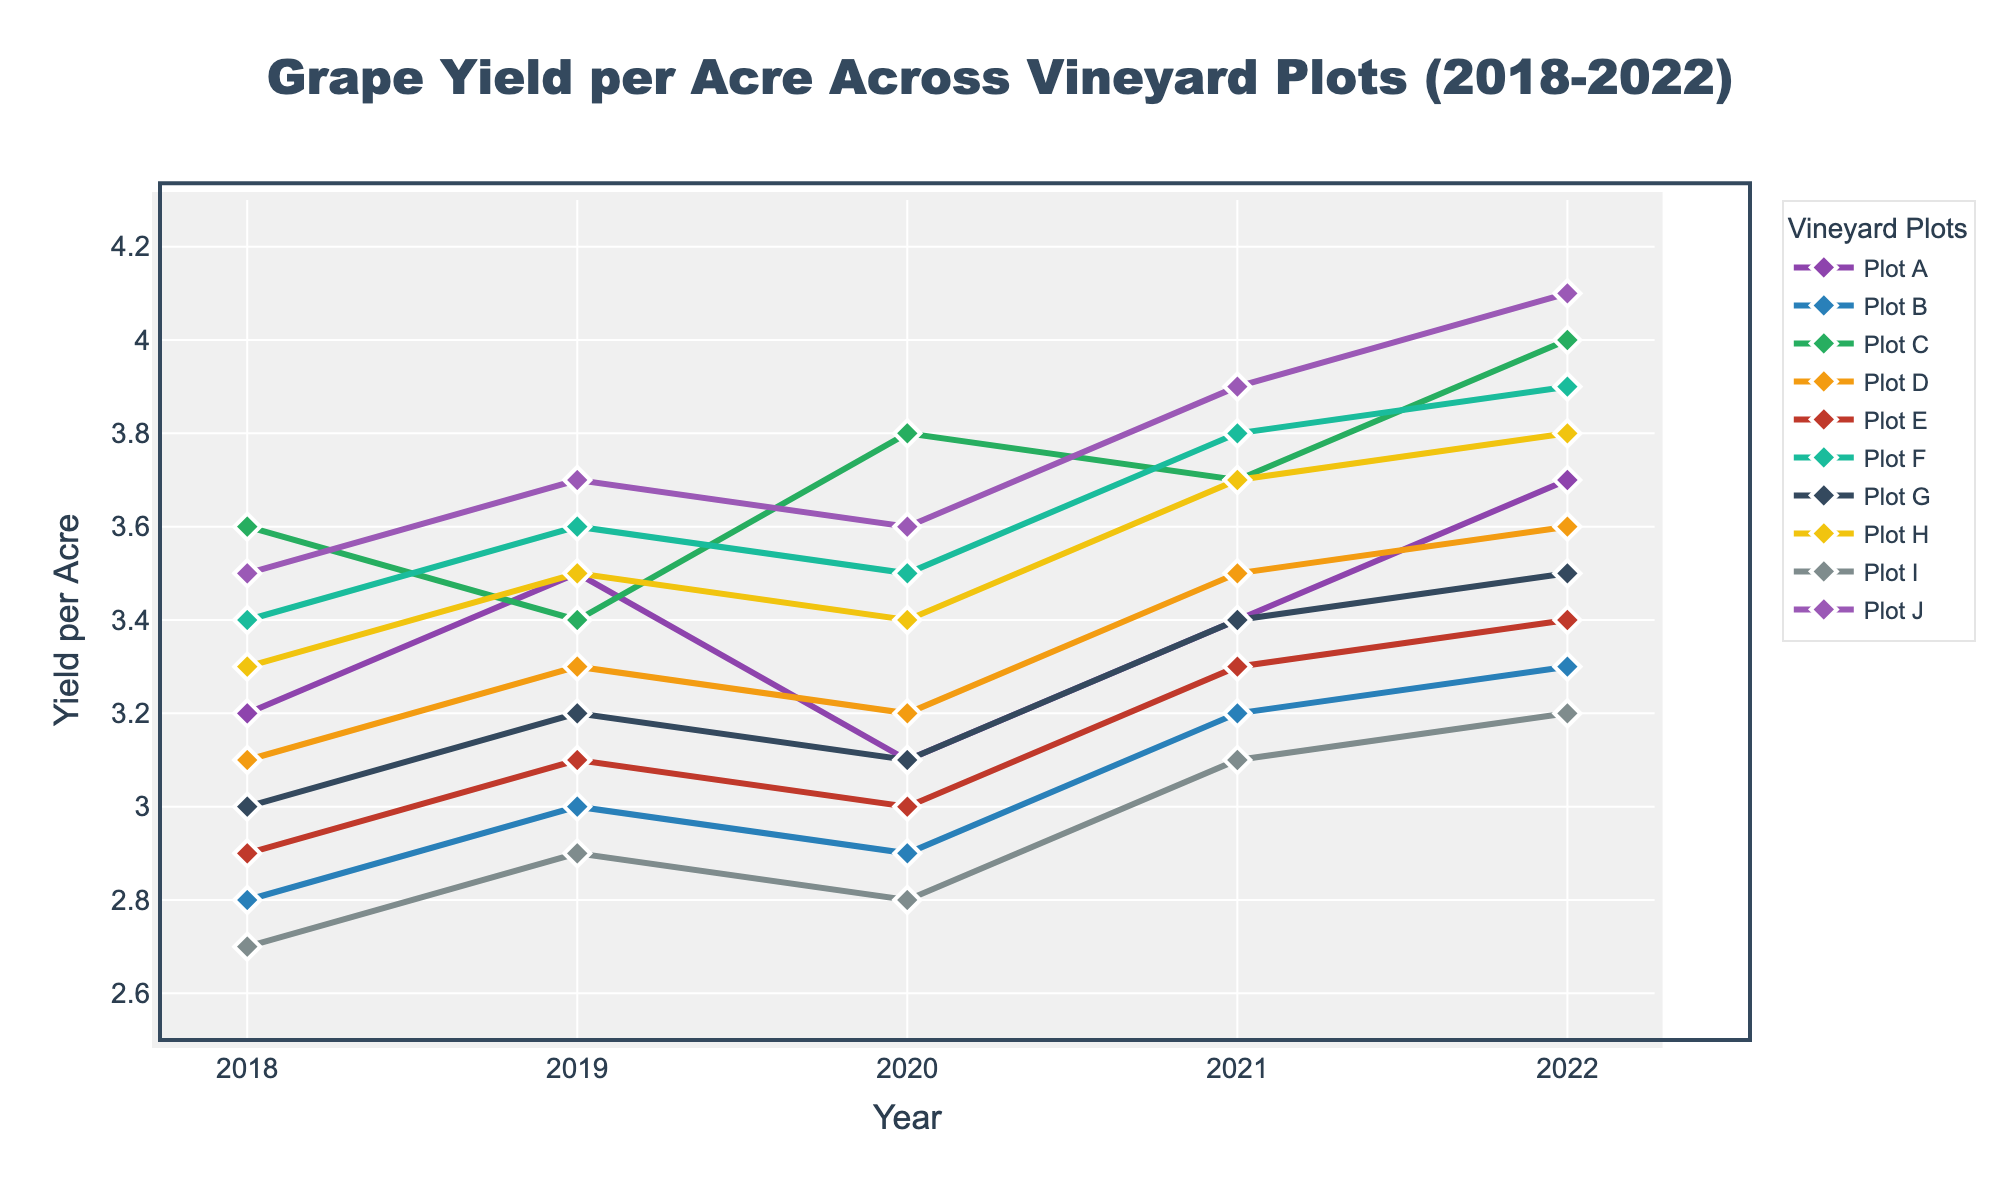What is the trend for Plot A from 2018 to 2022? Look at the line for Plot A and observe the data points for each year from 2018 to 2022. The yield starts at 3.2 in 2018, increases to 3.5 in 2019, drops slightly to 3.1 in 2020, rises again to 3.4 in 2021, and finally peaks at 3.7 in 2022. Therefore, the trend shows an overall increase with some fluctuations.
Answer: Increasing with fluctuations Which plot has the highest grape yield in 2022? Examine the endpoints of the lines for the year 2022. The line for Plot J ends at the highest point, which is 4.1 tons per acre in 2022.
Answer: Plot J Between 2018 and 2022, which plot shows the most consistent yield? Look for the plot whose line shows the least variability over the years. Plot E's line appears relatively flat compared to others, with yields of 2.9, 3.1, 3.0, 3.3, and 3.4 respectively. This indicates consistency.
Answer: Plot E Compare the yield trends of Plot C and Plot G. Which one shows a steeper overall increase? Observe the starting and ending points of the lines for Plots C and G from 2018 to 2022. Plot C starts at 3.6 and increases to 4.0, while Plot G starts at 3.0 and increases to 3.5. Plot C's difference (0.4) is greater than Plot G's (0.5), so C shows a steeper increase.
Answer: Plot C What is the average yield for Plot J over the five years? Sum the yields of Plot J for each year and then divide by 5. The values are 3.5, 3.7, 3.6, 3.9, and 4.1. The sum is (3.5 + 3.7 + 3.6 + 3.9 + 4.1) = 18.8. The average is 18.8 / 5 = 3.76.
Answer: 3.76 Which plots had a yield of exactly 3 tons per acre in any year from 2018 to 2022? Check each plot's yields for the given years to identify any instance of exactly 3.0 tons per acre. Plot B in 2019, Plot E in 2020, and Plot I in 2021 meet this criterion.
Answer: Plots B, E, and I How many plots achieved a yield greater than 3.5 tons per acre in 2019? Look at the data points for the year 2019 and count the plots with yields over 3.5. The plots meeting this criterion are A (3.5), F (3.6), H (3.5), and J (3.7).
Answer: 4 plots 